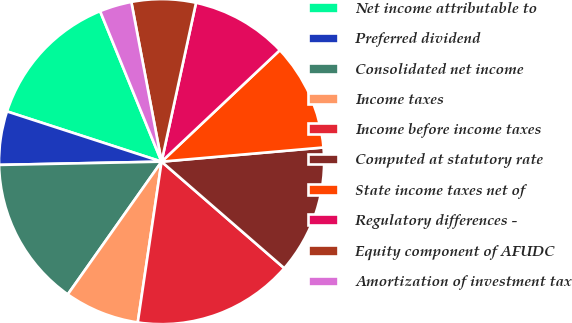<chart> <loc_0><loc_0><loc_500><loc_500><pie_chart><fcel>Net income attributable to<fcel>Preferred dividend<fcel>Consolidated net income<fcel>Income taxes<fcel>Income before income taxes<fcel>Computed at statutory rate<fcel>State income taxes net of<fcel>Regulatory differences -<fcel>Equity component of AFUDC<fcel>Amortization of investment tax<nl><fcel>13.83%<fcel>5.32%<fcel>14.89%<fcel>7.45%<fcel>15.96%<fcel>12.77%<fcel>10.64%<fcel>9.57%<fcel>6.38%<fcel>3.19%<nl></chart> 